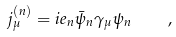Convert formula to latex. <formula><loc_0><loc_0><loc_500><loc_500>j _ { \mu } ^ { ( n ) } = i e _ { n } \bar { \psi } _ { n } \gamma _ { \mu } \psi _ { n } \quad ,</formula> 